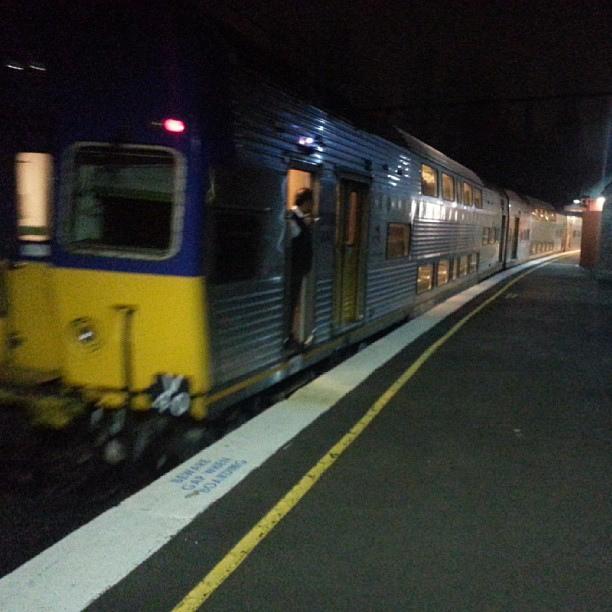What color is the ground?
Short answer required. Black. What colors are the train?
Write a very short answer. Yellow and blue. Are there any people on the train?
Quick response, please. Yes. Is it night time?
Short answer required. Yes. Is the train in motion?
Quick response, please. Yes. Is this a train station?
Be succinct. Yes. What color is the train?
Give a very brief answer. Silver. Is the trains headlight on?
Write a very short answer. No. Is the light on the train?
Quick response, please. Yes. Can anyone be seen on the train?
Quick response, please. Yes. 